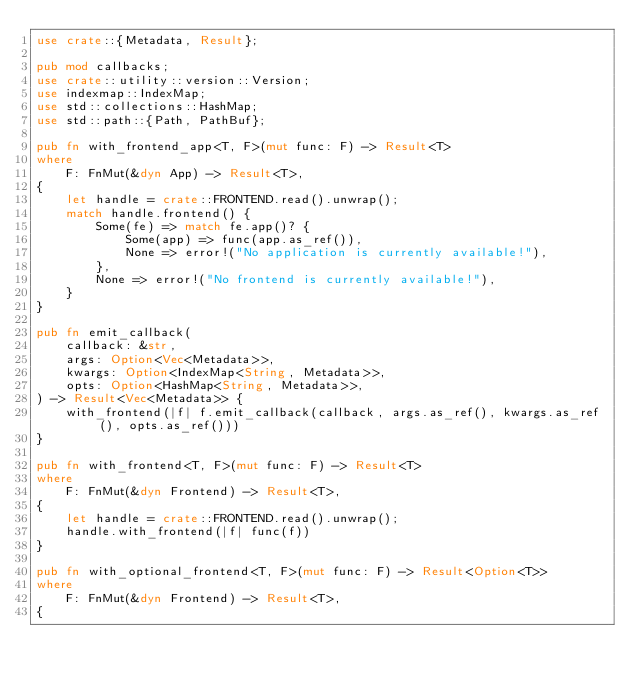<code> <loc_0><loc_0><loc_500><loc_500><_Rust_>use crate::{Metadata, Result};

pub mod callbacks;
use crate::utility::version::Version;
use indexmap::IndexMap;
use std::collections::HashMap;
use std::path::{Path, PathBuf};

pub fn with_frontend_app<T, F>(mut func: F) -> Result<T>
where
    F: FnMut(&dyn App) -> Result<T>,
{
    let handle = crate::FRONTEND.read().unwrap();
    match handle.frontend() {
        Some(fe) => match fe.app()? {
            Some(app) => func(app.as_ref()),
            None => error!("No application is currently available!"),
        },
        None => error!("No frontend is currently available!"),
    }
}

pub fn emit_callback(
    callback: &str,
    args: Option<Vec<Metadata>>,
    kwargs: Option<IndexMap<String, Metadata>>,
    opts: Option<HashMap<String, Metadata>>,
) -> Result<Vec<Metadata>> {
    with_frontend(|f| f.emit_callback(callback, args.as_ref(), kwargs.as_ref(), opts.as_ref()))
}

pub fn with_frontend<T, F>(mut func: F) -> Result<T>
where
    F: FnMut(&dyn Frontend) -> Result<T>,
{
    let handle = crate::FRONTEND.read().unwrap();
    handle.with_frontend(|f| func(f))
}

pub fn with_optional_frontend<T, F>(mut func: F) -> Result<Option<T>>
where
    F: FnMut(&dyn Frontend) -> Result<T>,
{</code> 